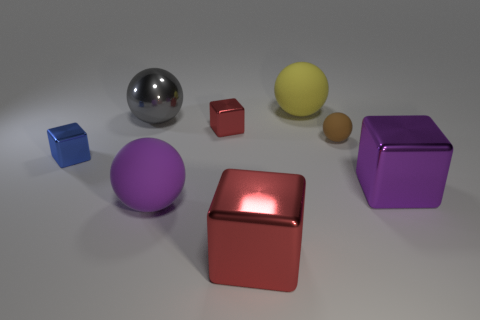Subtract 1 spheres. How many spheres are left? 3 Add 2 shiny cubes. How many objects exist? 10 Add 4 yellow matte spheres. How many yellow matte spheres exist? 5 Subtract 0 red spheres. How many objects are left? 8 Subtract all blue metal objects. Subtract all blue shiny cubes. How many objects are left? 6 Add 4 brown rubber things. How many brown rubber things are left? 5 